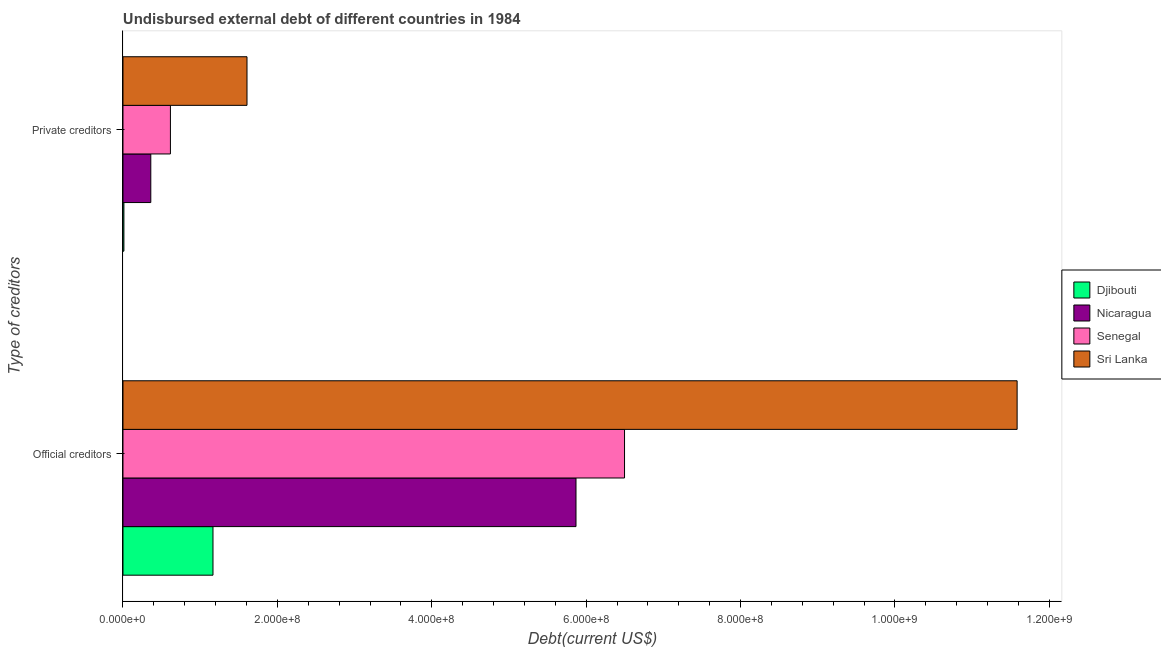Are the number of bars per tick equal to the number of legend labels?
Provide a short and direct response. Yes. How many bars are there on the 1st tick from the bottom?
Your answer should be very brief. 4. What is the label of the 1st group of bars from the top?
Ensure brevity in your answer.  Private creditors. What is the undisbursed external debt of official creditors in Senegal?
Make the answer very short. 6.50e+08. Across all countries, what is the maximum undisbursed external debt of official creditors?
Provide a short and direct response. 1.16e+09. Across all countries, what is the minimum undisbursed external debt of official creditors?
Your answer should be compact. 1.17e+08. In which country was the undisbursed external debt of official creditors maximum?
Keep it short and to the point. Sri Lanka. In which country was the undisbursed external debt of official creditors minimum?
Ensure brevity in your answer.  Djibouti. What is the total undisbursed external debt of private creditors in the graph?
Offer a terse response. 2.59e+08. What is the difference between the undisbursed external debt of official creditors in Nicaragua and that in Senegal?
Provide a succinct answer. -6.29e+07. What is the difference between the undisbursed external debt of official creditors in Nicaragua and the undisbursed external debt of private creditors in Djibouti?
Give a very brief answer. 5.86e+08. What is the average undisbursed external debt of private creditors per country?
Give a very brief answer. 6.48e+07. What is the difference between the undisbursed external debt of private creditors and undisbursed external debt of official creditors in Senegal?
Your answer should be very brief. -5.88e+08. What is the ratio of the undisbursed external debt of private creditors in Sri Lanka to that in Nicaragua?
Your answer should be compact. 4.46. In how many countries, is the undisbursed external debt of official creditors greater than the average undisbursed external debt of official creditors taken over all countries?
Your answer should be very brief. 2. What does the 3rd bar from the top in Official creditors represents?
Your answer should be compact. Nicaragua. What does the 2nd bar from the bottom in Official creditors represents?
Your response must be concise. Nicaragua. Are all the bars in the graph horizontal?
Offer a very short reply. Yes. What is the difference between two consecutive major ticks on the X-axis?
Your answer should be compact. 2.00e+08. Does the graph contain any zero values?
Your response must be concise. No. Where does the legend appear in the graph?
Ensure brevity in your answer.  Center right. How many legend labels are there?
Offer a terse response. 4. How are the legend labels stacked?
Offer a terse response. Vertical. What is the title of the graph?
Your answer should be very brief. Undisbursed external debt of different countries in 1984. Does "Cote d'Ivoire" appear as one of the legend labels in the graph?
Your response must be concise. No. What is the label or title of the X-axis?
Your answer should be compact. Debt(current US$). What is the label or title of the Y-axis?
Offer a terse response. Type of creditors. What is the Debt(current US$) in Djibouti in Official creditors?
Ensure brevity in your answer.  1.17e+08. What is the Debt(current US$) of Nicaragua in Official creditors?
Offer a terse response. 5.87e+08. What is the Debt(current US$) in Senegal in Official creditors?
Ensure brevity in your answer.  6.50e+08. What is the Debt(current US$) of Sri Lanka in Official creditors?
Your answer should be very brief. 1.16e+09. What is the Debt(current US$) in Djibouti in Private creditors?
Offer a terse response. 1.19e+06. What is the Debt(current US$) in Nicaragua in Private creditors?
Keep it short and to the point. 3.60e+07. What is the Debt(current US$) of Senegal in Private creditors?
Your response must be concise. 6.14e+07. What is the Debt(current US$) in Sri Lanka in Private creditors?
Your answer should be very brief. 1.61e+08. Across all Type of creditors, what is the maximum Debt(current US$) in Djibouti?
Offer a very short reply. 1.17e+08. Across all Type of creditors, what is the maximum Debt(current US$) of Nicaragua?
Ensure brevity in your answer.  5.87e+08. Across all Type of creditors, what is the maximum Debt(current US$) of Senegal?
Provide a short and direct response. 6.50e+08. Across all Type of creditors, what is the maximum Debt(current US$) in Sri Lanka?
Your answer should be very brief. 1.16e+09. Across all Type of creditors, what is the minimum Debt(current US$) in Djibouti?
Your answer should be compact. 1.19e+06. Across all Type of creditors, what is the minimum Debt(current US$) in Nicaragua?
Your answer should be very brief. 3.60e+07. Across all Type of creditors, what is the minimum Debt(current US$) of Senegal?
Keep it short and to the point. 6.14e+07. Across all Type of creditors, what is the minimum Debt(current US$) in Sri Lanka?
Offer a very short reply. 1.61e+08. What is the total Debt(current US$) of Djibouti in the graph?
Give a very brief answer. 1.18e+08. What is the total Debt(current US$) of Nicaragua in the graph?
Give a very brief answer. 6.23e+08. What is the total Debt(current US$) of Senegal in the graph?
Give a very brief answer. 7.11e+08. What is the total Debt(current US$) in Sri Lanka in the graph?
Your answer should be very brief. 1.32e+09. What is the difference between the Debt(current US$) of Djibouti in Official creditors and that in Private creditors?
Offer a very short reply. 1.15e+08. What is the difference between the Debt(current US$) of Nicaragua in Official creditors and that in Private creditors?
Ensure brevity in your answer.  5.51e+08. What is the difference between the Debt(current US$) in Senegal in Official creditors and that in Private creditors?
Provide a succinct answer. 5.88e+08. What is the difference between the Debt(current US$) of Sri Lanka in Official creditors and that in Private creditors?
Provide a short and direct response. 9.98e+08. What is the difference between the Debt(current US$) of Djibouti in Official creditors and the Debt(current US$) of Nicaragua in Private creditors?
Provide a succinct answer. 8.06e+07. What is the difference between the Debt(current US$) of Djibouti in Official creditors and the Debt(current US$) of Senegal in Private creditors?
Offer a terse response. 5.51e+07. What is the difference between the Debt(current US$) in Djibouti in Official creditors and the Debt(current US$) in Sri Lanka in Private creditors?
Your answer should be compact. -4.41e+07. What is the difference between the Debt(current US$) in Nicaragua in Official creditors and the Debt(current US$) in Senegal in Private creditors?
Make the answer very short. 5.25e+08. What is the difference between the Debt(current US$) in Nicaragua in Official creditors and the Debt(current US$) in Sri Lanka in Private creditors?
Make the answer very short. 4.26e+08. What is the difference between the Debt(current US$) of Senegal in Official creditors and the Debt(current US$) of Sri Lanka in Private creditors?
Ensure brevity in your answer.  4.89e+08. What is the average Debt(current US$) in Djibouti per Type of creditors?
Make the answer very short. 5.89e+07. What is the average Debt(current US$) of Nicaragua per Type of creditors?
Keep it short and to the point. 3.11e+08. What is the average Debt(current US$) of Senegal per Type of creditors?
Provide a succinct answer. 3.56e+08. What is the average Debt(current US$) of Sri Lanka per Type of creditors?
Ensure brevity in your answer.  6.59e+08. What is the difference between the Debt(current US$) of Djibouti and Debt(current US$) of Nicaragua in Official creditors?
Provide a short and direct response. -4.70e+08. What is the difference between the Debt(current US$) of Djibouti and Debt(current US$) of Senegal in Official creditors?
Keep it short and to the point. -5.33e+08. What is the difference between the Debt(current US$) of Djibouti and Debt(current US$) of Sri Lanka in Official creditors?
Your answer should be very brief. -1.04e+09. What is the difference between the Debt(current US$) of Nicaragua and Debt(current US$) of Senegal in Official creditors?
Offer a terse response. -6.29e+07. What is the difference between the Debt(current US$) of Nicaragua and Debt(current US$) of Sri Lanka in Official creditors?
Provide a succinct answer. -5.71e+08. What is the difference between the Debt(current US$) in Senegal and Debt(current US$) in Sri Lanka in Official creditors?
Keep it short and to the point. -5.09e+08. What is the difference between the Debt(current US$) in Djibouti and Debt(current US$) in Nicaragua in Private creditors?
Offer a terse response. -3.48e+07. What is the difference between the Debt(current US$) of Djibouti and Debt(current US$) of Senegal in Private creditors?
Your response must be concise. -6.03e+07. What is the difference between the Debt(current US$) in Djibouti and Debt(current US$) in Sri Lanka in Private creditors?
Your response must be concise. -1.59e+08. What is the difference between the Debt(current US$) in Nicaragua and Debt(current US$) in Senegal in Private creditors?
Offer a terse response. -2.54e+07. What is the difference between the Debt(current US$) of Nicaragua and Debt(current US$) of Sri Lanka in Private creditors?
Your answer should be compact. -1.25e+08. What is the difference between the Debt(current US$) of Senegal and Debt(current US$) of Sri Lanka in Private creditors?
Give a very brief answer. -9.92e+07. What is the ratio of the Debt(current US$) in Djibouti in Official creditors to that in Private creditors?
Offer a very short reply. 97.81. What is the ratio of the Debt(current US$) in Nicaragua in Official creditors to that in Private creditors?
Provide a short and direct response. 16.29. What is the ratio of the Debt(current US$) of Senegal in Official creditors to that in Private creditors?
Give a very brief answer. 10.57. What is the ratio of the Debt(current US$) in Sri Lanka in Official creditors to that in Private creditors?
Give a very brief answer. 7.21. What is the difference between the highest and the second highest Debt(current US$) in Djibouti?
Ensure brevity in your answer.  1.15e+08. What is the difference between the highest and the second highest Debt(current US$) in Nicaragua?
Your answer should be very brief. 5.51e+08. What is the difference between the highest and the second highest Debt(current US$) of Senegal?
Give a very brief answer. 5.88e+08. What is the difference between the highest and the second highest Debt(current US$) in Sri Lanka?
Make the answer very short. 9.98e+08. What is the difference between the highest and the lowest Debt(current US$) in Djibouti?
Your answer should be very brief. 1.15e+08. What is the difference between the highest and the lowest Debt(current US$) of Nicaragua?
Provide a succinct answer. 5.51e+08. What is the difference between the highest and the lowest Debt(current US$) of Senegal?
Your response must be concise. 5.88e+08. What is the difference between the highest and the lowest Debt(current US$) in Sri Lanka?
Provide a short and direct response. 9.98e+08. 